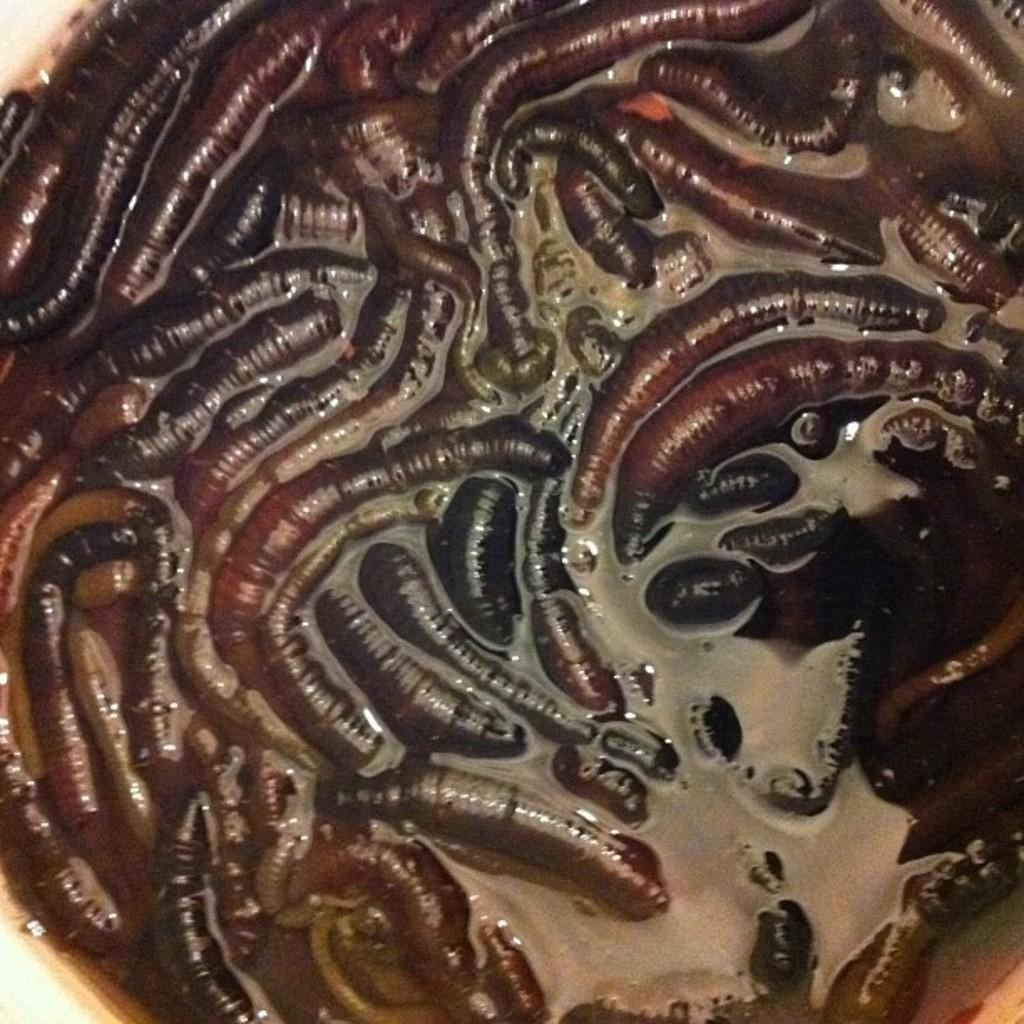What type of creatures are present in the image? There are worms in the image. Where are the worms located? The worms are in a container. What type of sea creature is present in the image? There is no sea creature present in the image; it features worms in a container. Can you read the prose written on the receipt in the image? There is no receipt or prose present in the image. 